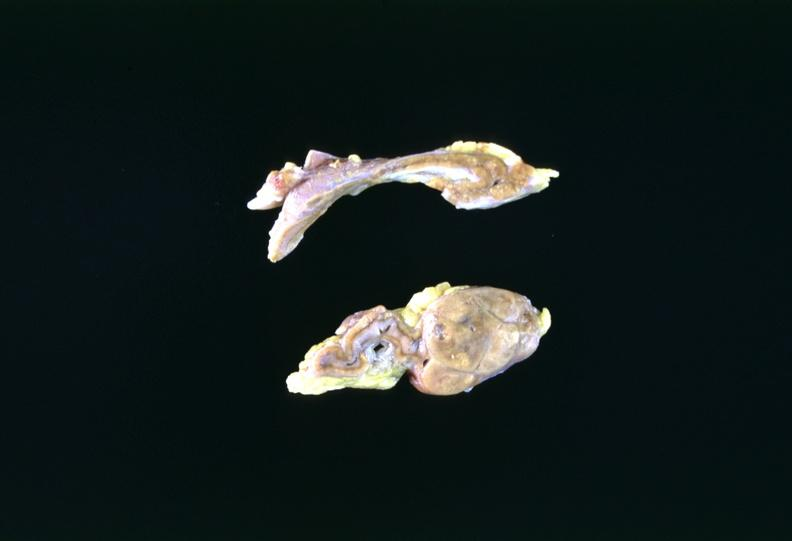where does this belong to?
Answer the question using a single word or phrase. Endocrine system 